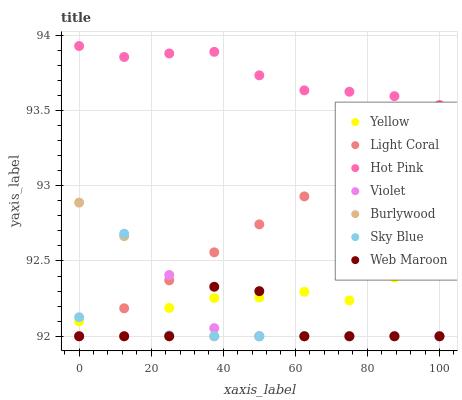Does Violet have the minimum area under the curve?
Answer yes or no. Yes. Does Hot Pink have the maximum area under the curve?
Answer yes or no. Yes. Does Web Maroon have the minimum area under the curve?
Answer yes or no. No. Does Web Maroon have the maximum area under the curve?
Answer yes or no. No. Is Light Coral the smoothest?
Answer yes or no. Yes. Is Sky Blue the roughest?
Answer yes or no. Yes. Is Hot Pink the smoothest?
Answer yes or no. No. Is Hot Pink the roughest?
Answer yes or no. No. Does Burlywood have the lowest value?
Answer yes or no. Yes. Does Hot Pink have the lowest value?
Answer yes or no. No. Does Hot Pink have the highest value?
Answer yes or no. Yes. Does Web Maroon have the highest value?
Answer yes or no. No. Is Violet less than Hot Pink?
Answer yes or no. Yes. Is Hot Pink greater than Violet?
Answer yes or no. Yes. Does Light Coral intersect Web Maroon?
Answer yes or no. Yes. Is Light Coral less than Web Maroon?
Answer yes or no. No. Is Light Coral greater than Web Maroon?
Answer yes or no. No. Does Violet intersect Hot Pink?
Answer yes or no. No. 